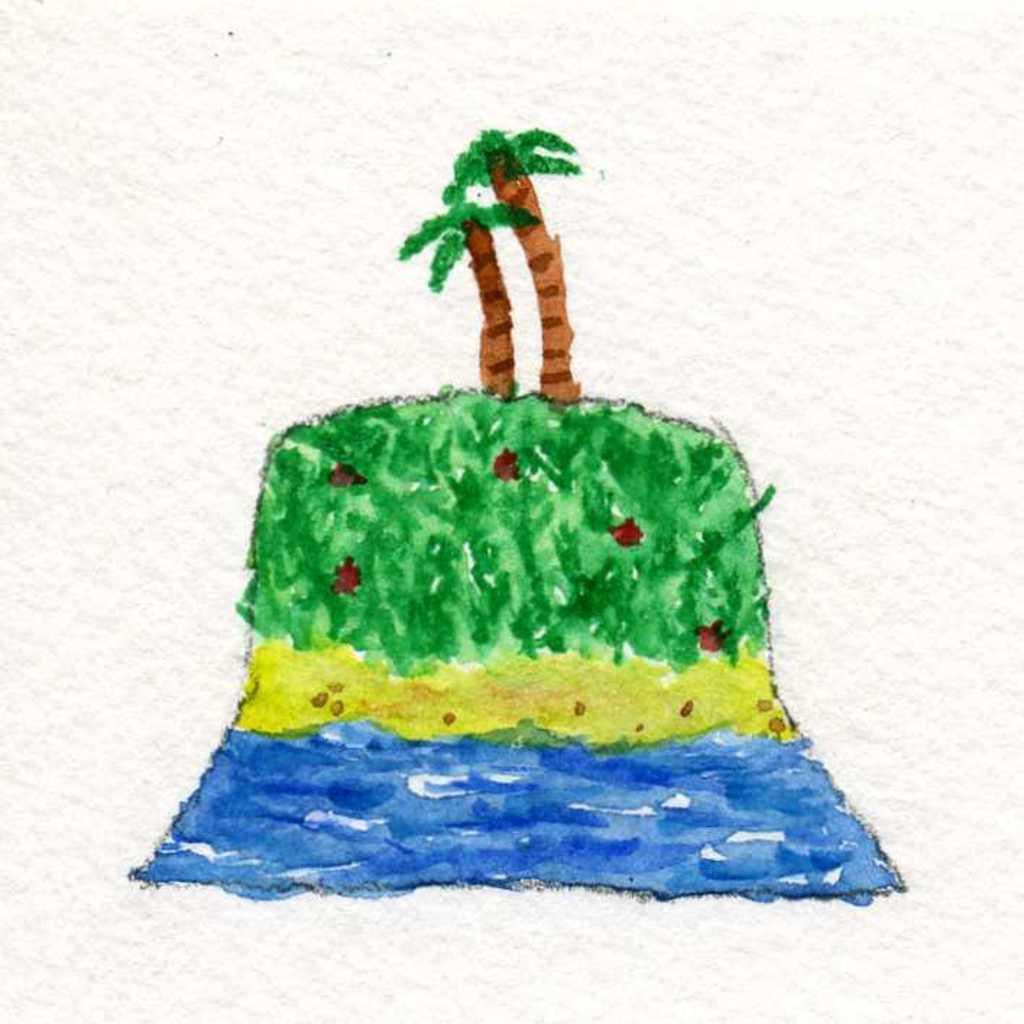What type of paintings are depicted in the image? There are paintings of trees, water, and grass in the image. Can you describe the subjects of the paintings? The paintings depict trees, water, and grass. Are there any other elements present in the paintings? The provided facts do not mention any other elements in the paintings. What type of church is visible in the painting of trees? There is no church present in the painting of trees; the painting only depicts trees. How many balls can be seen in the painting of water? There are no balls present in the painting of water; the painting only depicts water. 